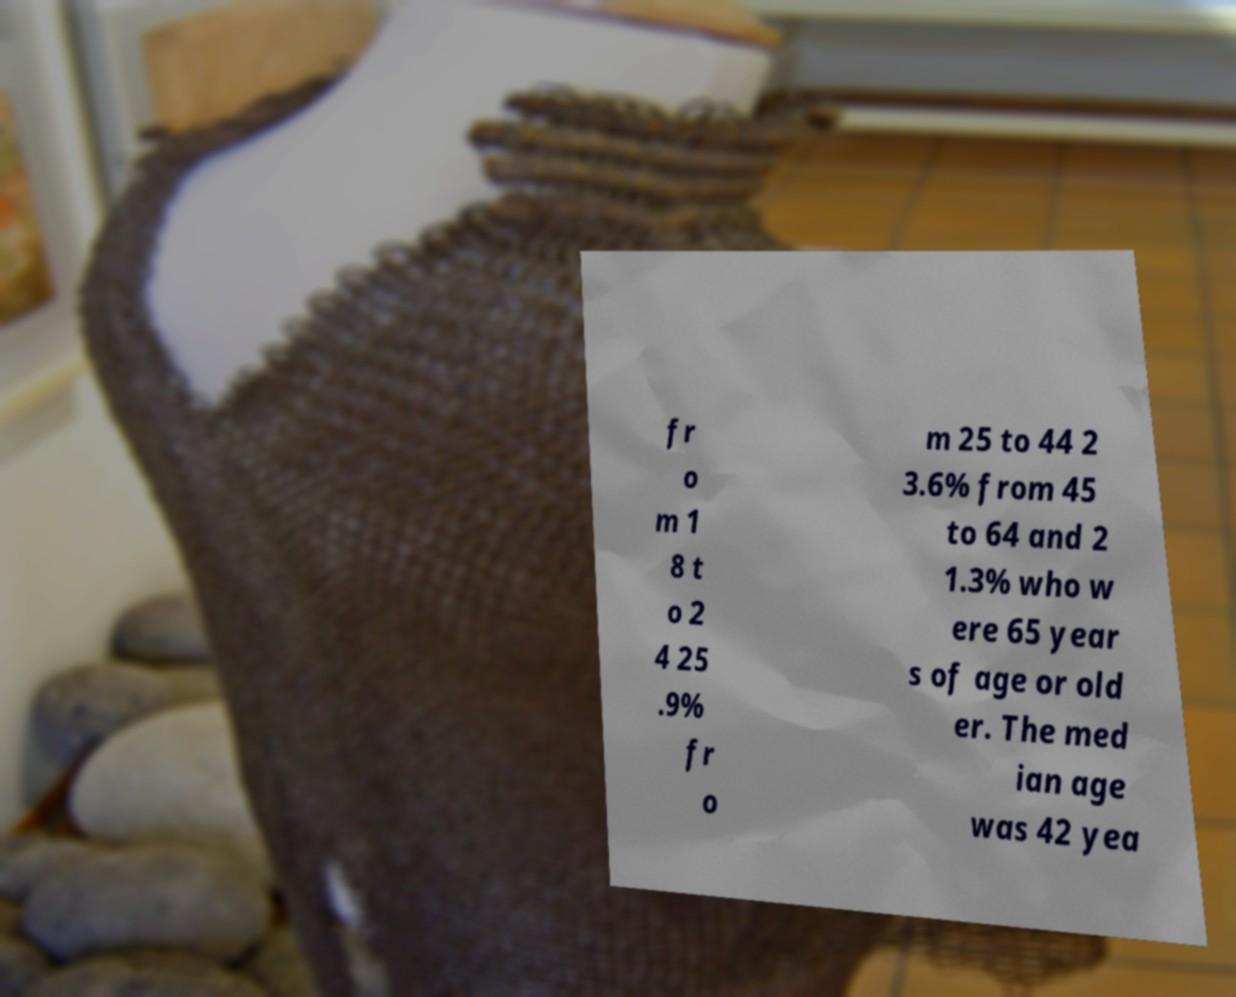Can you read and provide the text displayed in the image?This photo seems to have some interesting text. Can you extract and type it out for me? fr o m 1 8 t o 2 4 25 .9% fr o m 25 to 44 2 3.6% from 45 to 64 and 2 1.3% who w ere 65 year s of age or old er. The med ian age was 42 yea 